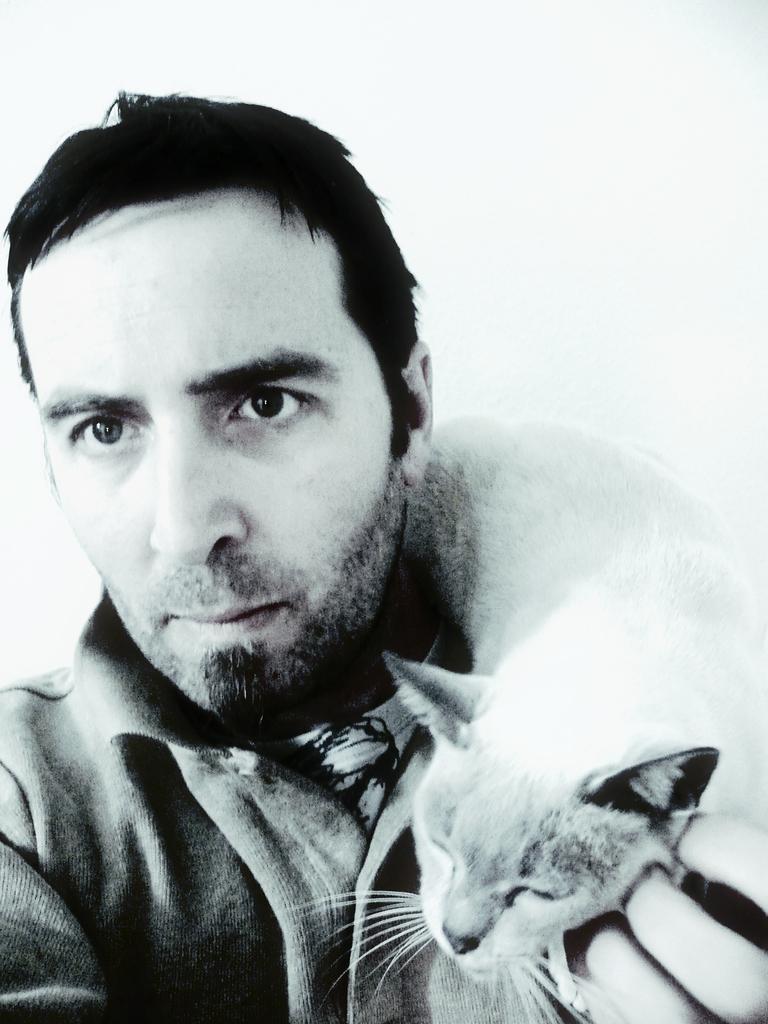How would you summarize this image in a sentence or two? In this image a man wearing a coat is holding a cat on his shoulder. 